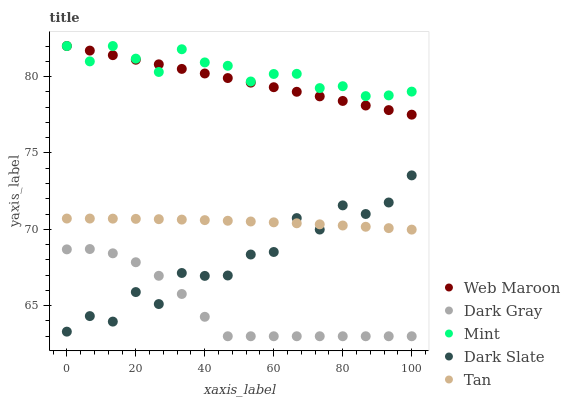Does Dark Gray have the minimum area under the curve?
Answer yes or no. Yes. Does Mint have the maximum area under the curve?
Answer yes or no. Yes. Does Tan have the minimum area under the curve?
Answer yes or no. No. Does Tan have the maximum area under the curve?
Answer yes or no. No. Is Web Maroon the smoothest?
Answer yes or no. Yes. Is Dark Slate the roughest?
Answer yes or no. Yes. Is Mint the smoothest?
Answer yes or no. No. Is Mint the roughest?
Answer yes or no. No. Does Dark Gray have the lowest value?
Answer yes or no. Yes. Does Tan have the lowest value?
Answer yes or no. No. Does Web Maroon have the highest value?
Answer yes or no. Yes. Does Tan have the highest value?
Answer yes or no. No. Is Dark Slate less than Web Maroon?
Answer yes or no. Yes. Is Mint greater than Dark Gray?
Answer yes or no. Yes. Does Dark Gray intersect Dark Slate?
Answer yes or no. Yes. Is Dark Gray less than Dark Slate?
Answer yes or no. No. Is Dark Gray greater than Dark Slate?
Answer yes or no. No. Does Dark Slate intersect Web Maroon?
Answer yes or no. No. 